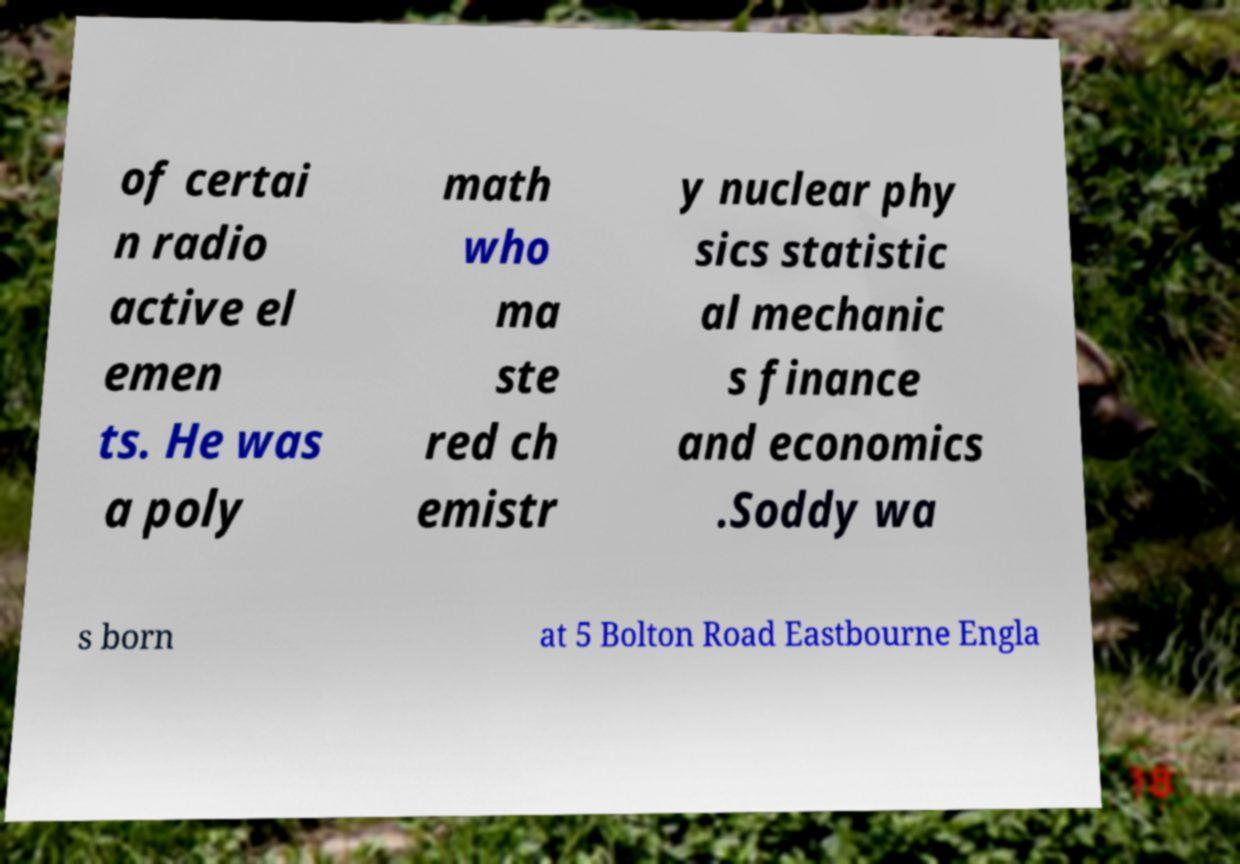Can you accurately transcribe the text from the provided image for me? of certai n radio active el emen ts. He was a poly math who ma ste red ch emistr y nuclear phy sics statistic al mechanic s finance and economics .Soddy wa s born at 5 Bolton Road Eastbourne Engla 